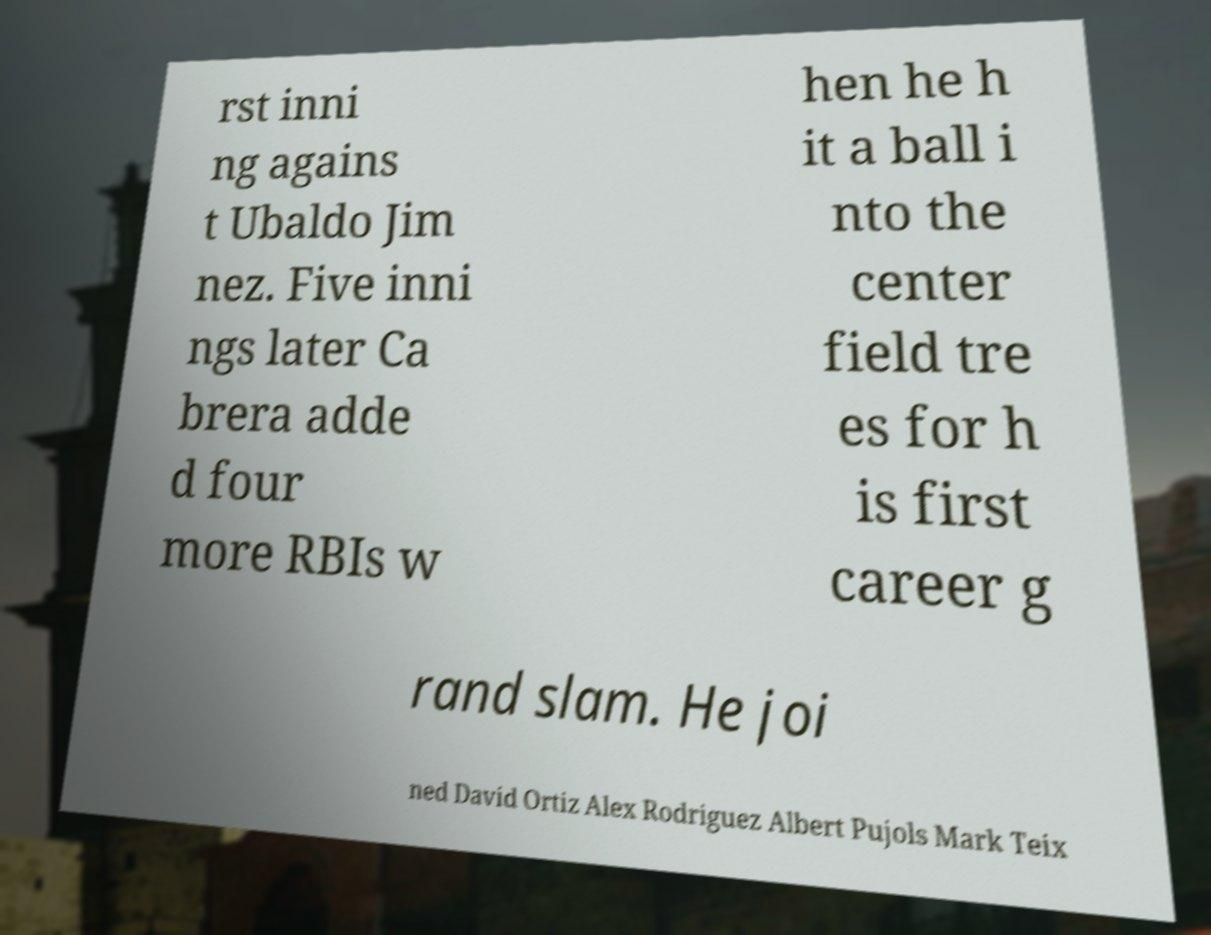Can you read and provide the text displayed in the image?This photo seems to have some interesting text. Can you extract and type it out for me? rst inni ng agains t Ubaldo Jim nez. Five inni ngs later Ca brera adde d four more RBIs w hen he h it a ball i nto the center field tre es for h is first career g rand slam. He joi ned David Ortiz Alex Rodriguez Albert Pujols Mark Teix 